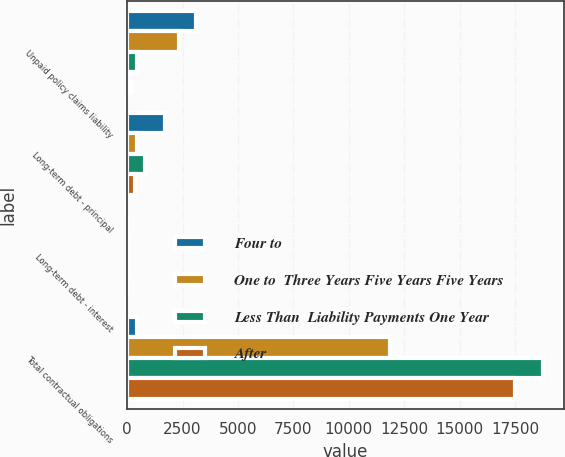Convert chart to OTSL. <chart><loc_0><loc_0><loc_500><loc_500><stacked_bar_chart><ecel><fcel>Unpaid policy claims liability<fcel>Long-term debt - principal<fcel>Long-term debt - interest<fcel>Total contractual obligations<nl><fcel>Four to<fcel>3118<fcel>1713<fcel>6<fcel>450<nl><fcel>One to  Three Years Five Years Five Years<fcel>2318<fcel>450<fcel>21<fcel>11847<nl><fcel>Less Than  Liability Payments One Year<fcel>422<fcel>824<fcel>29<fcel>18777<nl><fcel>After<fcel>188<fcel>329<fcel>7<fcel>17508<nl></chart> 